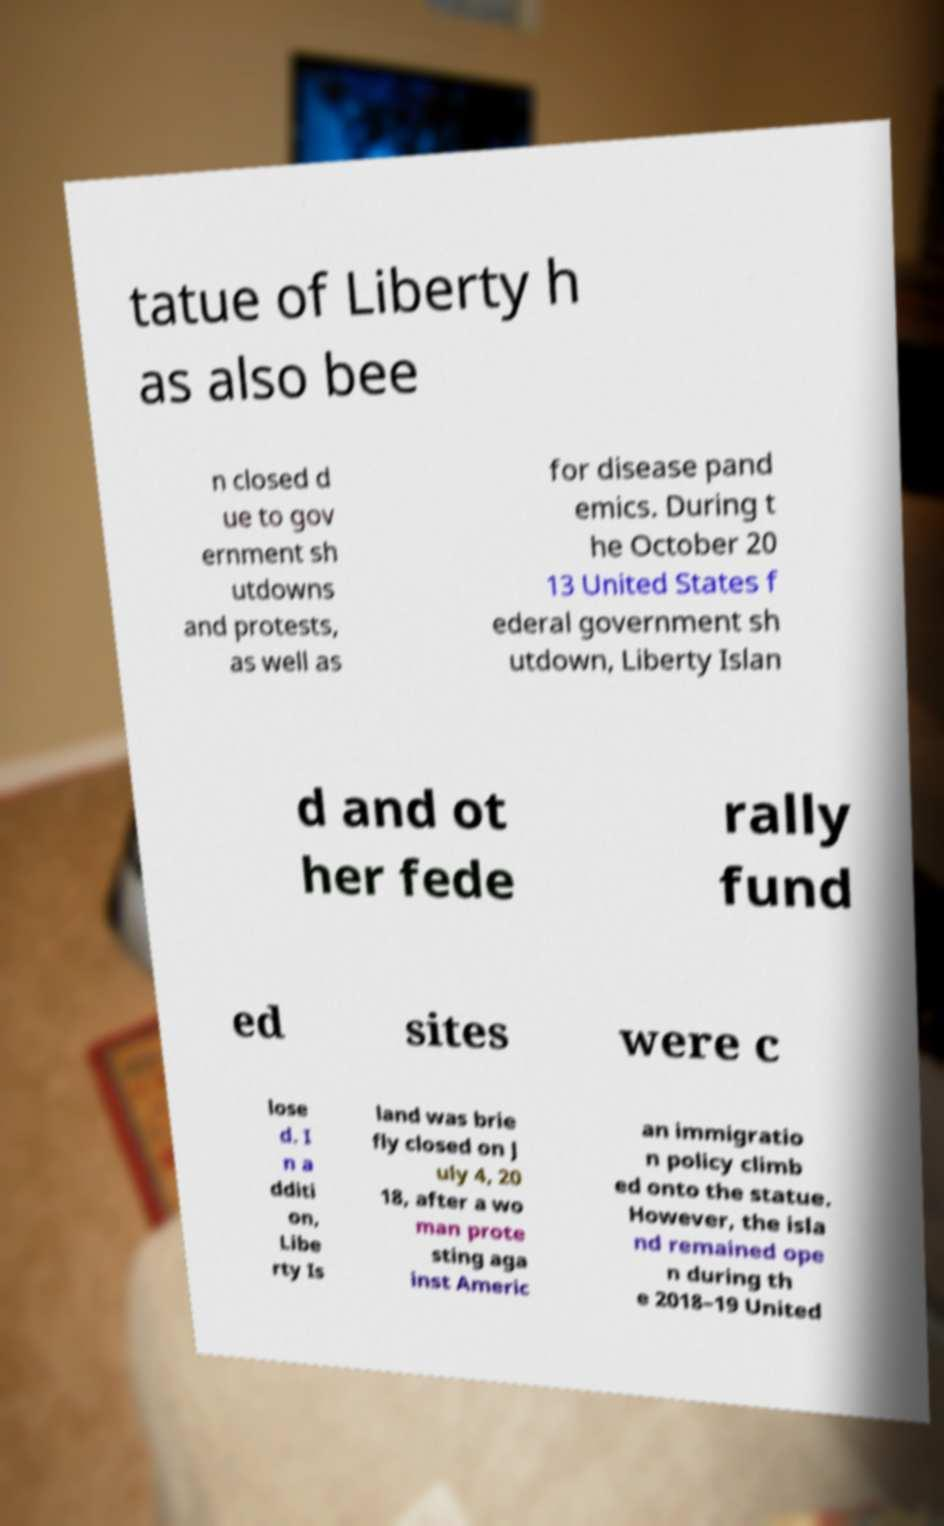There's text embedded in this image that I need extracted. Can you transcribe it verbatim? tatue of Liberty h as also bee n closed d ue to gov ernment sh utdowns and protests, as well as for disease pand emics. During t he October 20 13 United States f ederal government sh utdown, Liberty Islan d and ot her fede rally fund ed sites were c lose d. I n a dditi on, Libe rty Is land was brie fly closed on J uly 4, 20 18, after a wo man prote sting aga inst Americ an immigratio n policy climb ed onto the statue. However, the isla nd remained ope n during th e 2018–19 United 